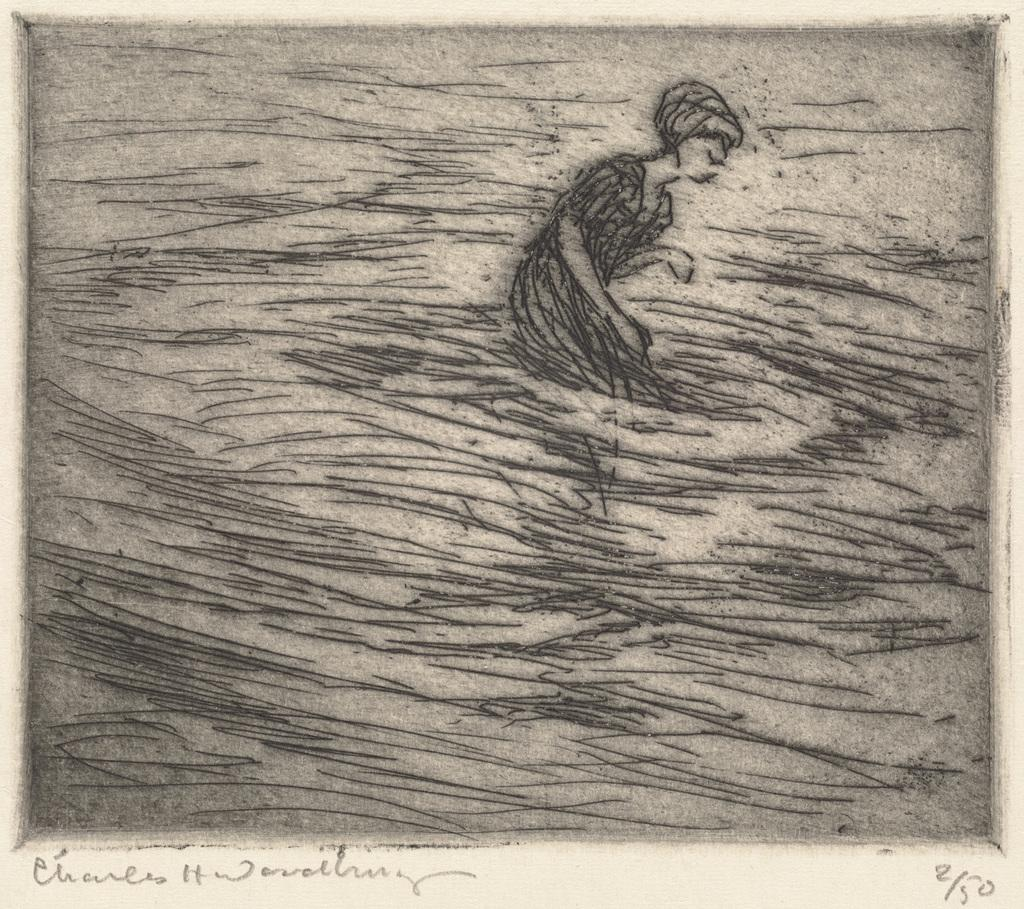What is present on the poster in the image? There is a drawing on the poster. What else can be seen on the poster besides the drawing? There is text written on the poster. What year is depicted in the drawing on the poster? There is no year depicted in the drawing on the poster, as the facts provided do not mention any specific time period or date. 